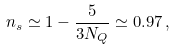<formula> <loc_0><loc_0><loc_500><loc_500>n _ { s } \simeq 1 - \frac { 5 } { 3 N _ { Q } } \simeq 0 . 9 7 \, ,</formula> 